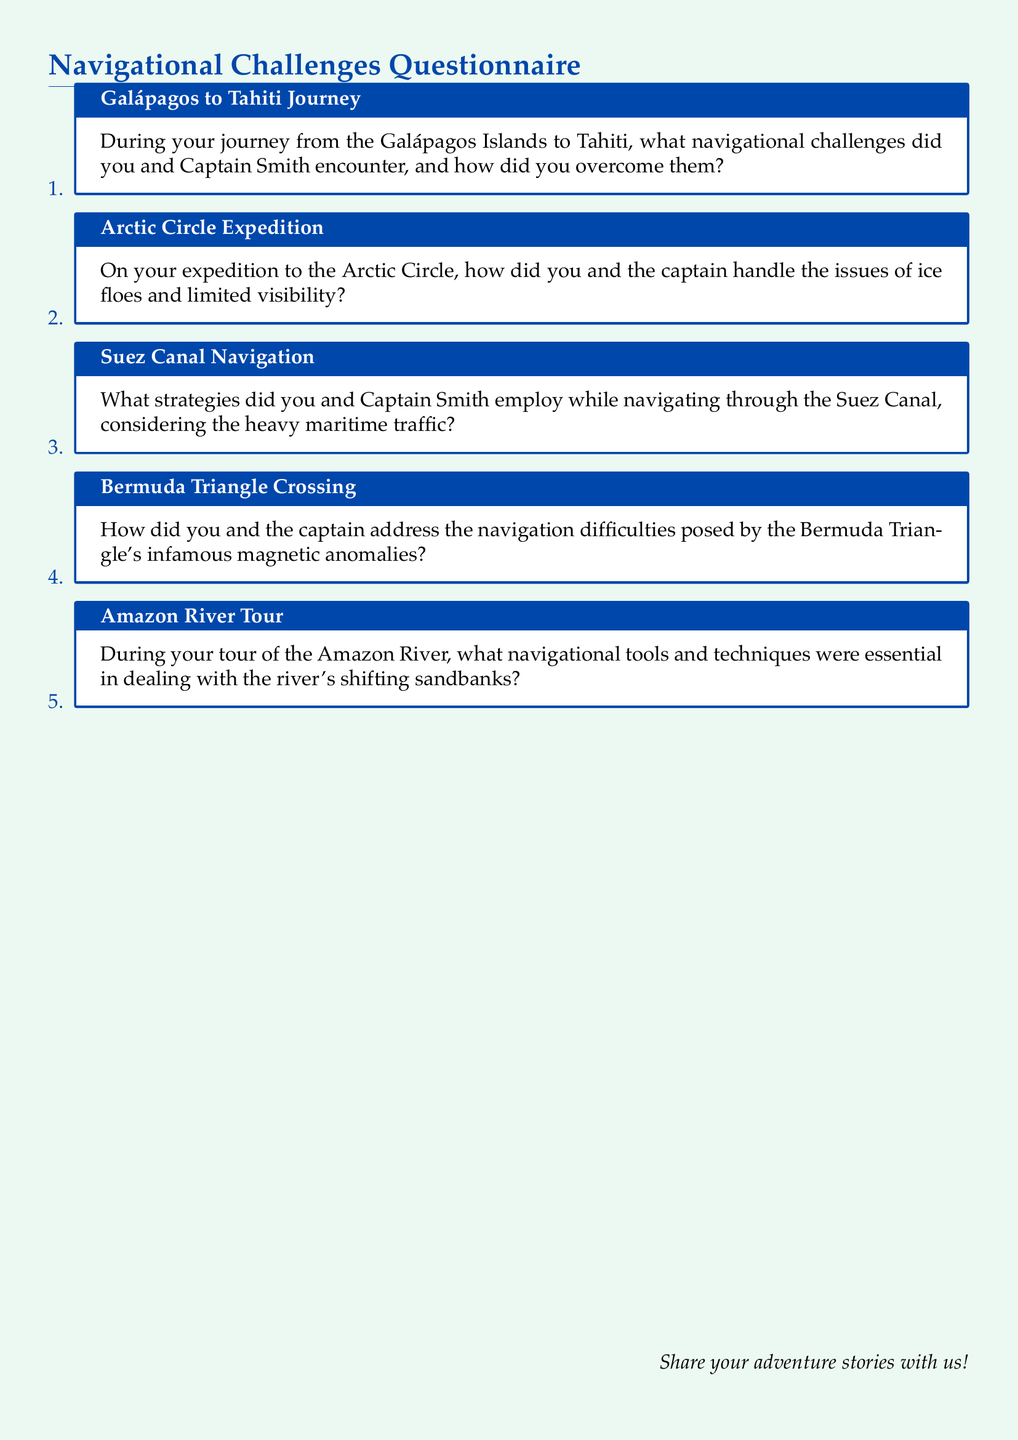What is the title of the document? The title of the document is centered at the top and reads "Navigational Challenges Questionnaire."
Answer: Navigational Challenges Questionnaire How many journeys are mentioned in the document? The document lists five distinct journeys or expeditions related to navigational challenges.
Answer: 5 What is the first journey listed? The first journey mentioned in the document is from the Galápagos Islands to Tahiti.
Answer: Galápagos to Tahiti Journey What specific navigational issue is posed in the Bermuda Triangle? The document states that the navigational difficulty in the Bermuda Triangle arises from infamous magnetic anomalies.
Answer: Magnetic anomalies What is the main navigational tool addressed in the Amazon River Tour? The document highlights the essential navigational tools and techniques needed to navigate the river's shifting sandbanks.
Answer: Navigational tools and techniques What was Captain Smith's role in the journeys? Captain Smith is mentioned as a key figure who encountered navigational challenges alongside the blogger.
Answer: Captain 